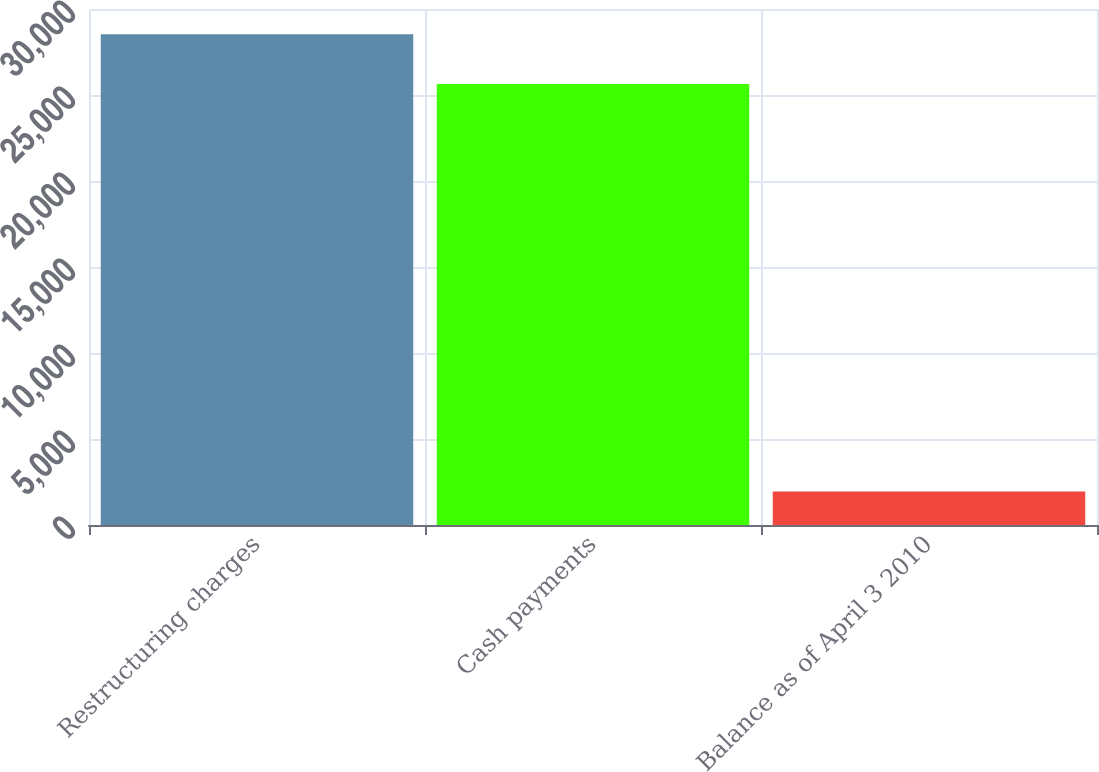Convert chart. <chart><loc_0><loc_0><loc_500><loc_500><bar_chart><fcel>Restructuring charges<fcel>Cash payments<fcel>Balance as of April 3 2010<nl><fcel>28531<fcel>25633<fcel>1953<nl></chart> 